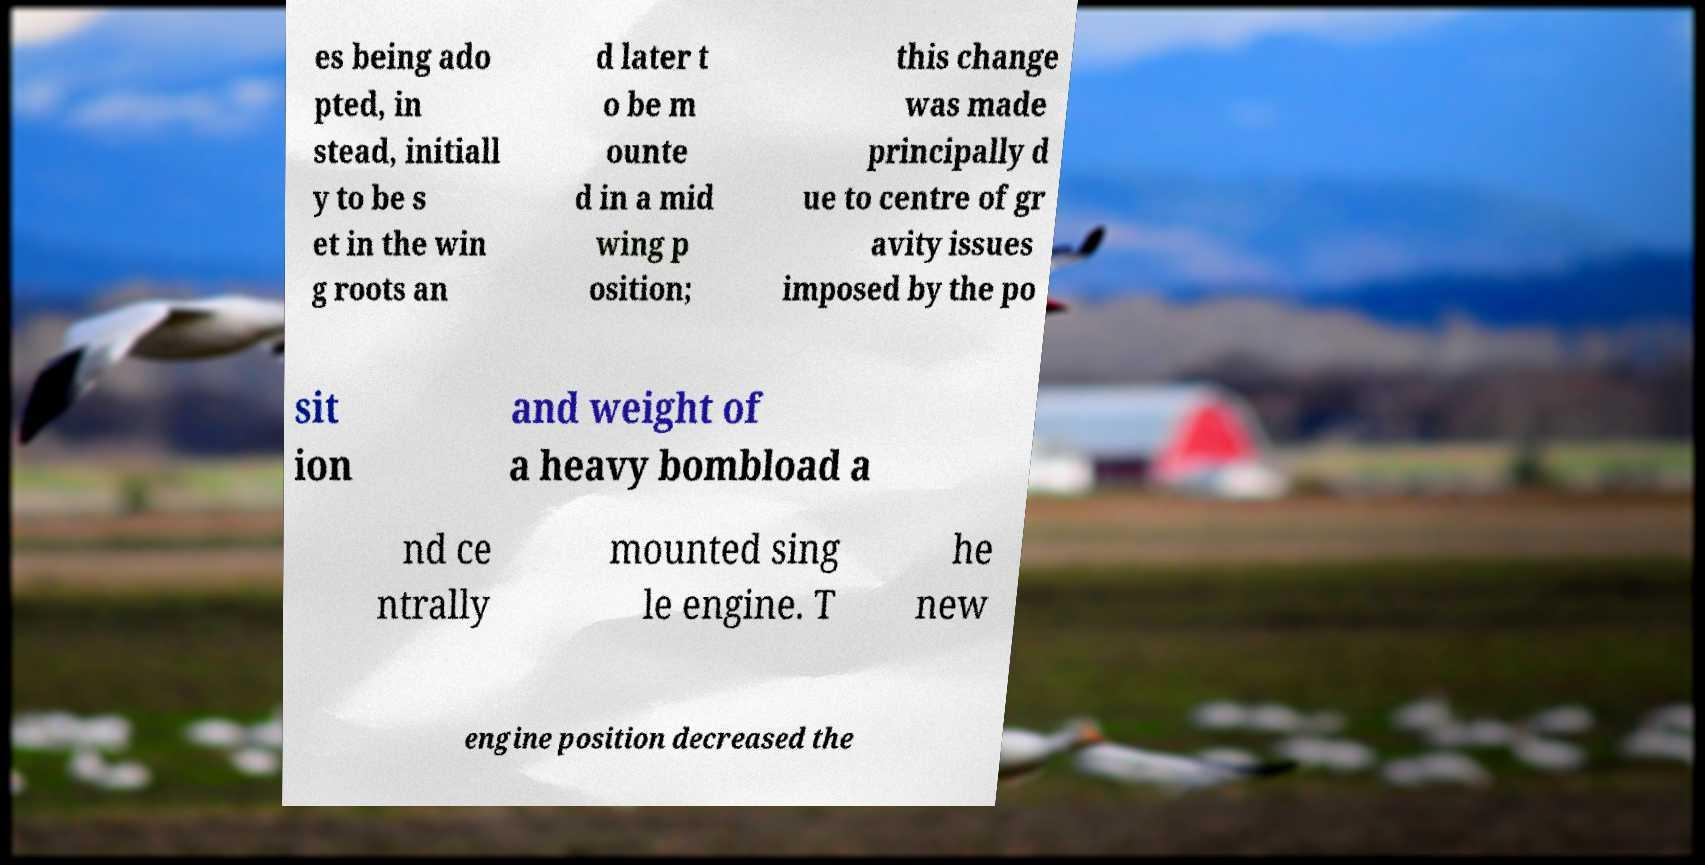What messages or text are displayed in this image? I need them in a readable, typed format. es being ado pted, in stead, initiall y to be s et in the win g roots an d later t o be m ounte d in a mid wing p osition; this change was made principally d ue to centre of gr avity issues imposed by the po sit ion and weight of a heavy bombload a nd ce ntrally mounted sing le engine. T he new engine position decreased the 